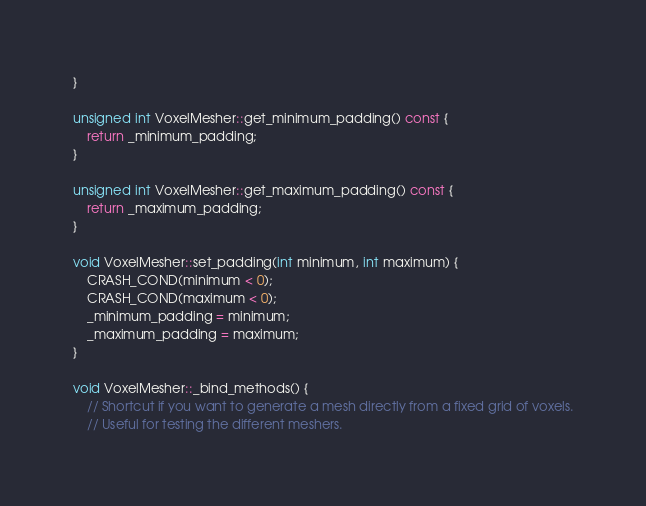<code> <loc_0><loc_0><loc_500><loc_500><_C++_>}

unsigned int VoxelMesher::get_minimum_padding() const {
	return _minimum_padding;
}

unsigned int VoxelMesher::get_maximum_padding() const {
	return _maximum_padding;
}

void VoxelMesher::set_padding(int minimum, int maximum) {
	CRASH_COND(minimum < 0);
	CRASH_COND(maximum < 0);
	_minimum_padding = minimum;
	_maximum_padding = maximum;
}

void VoxelMesher::_bind_methods() {
	// Shortcut if you want to generate a mesh directly from a fixed grid of voxels.
	// Useful for testing the different meshers.</code> 